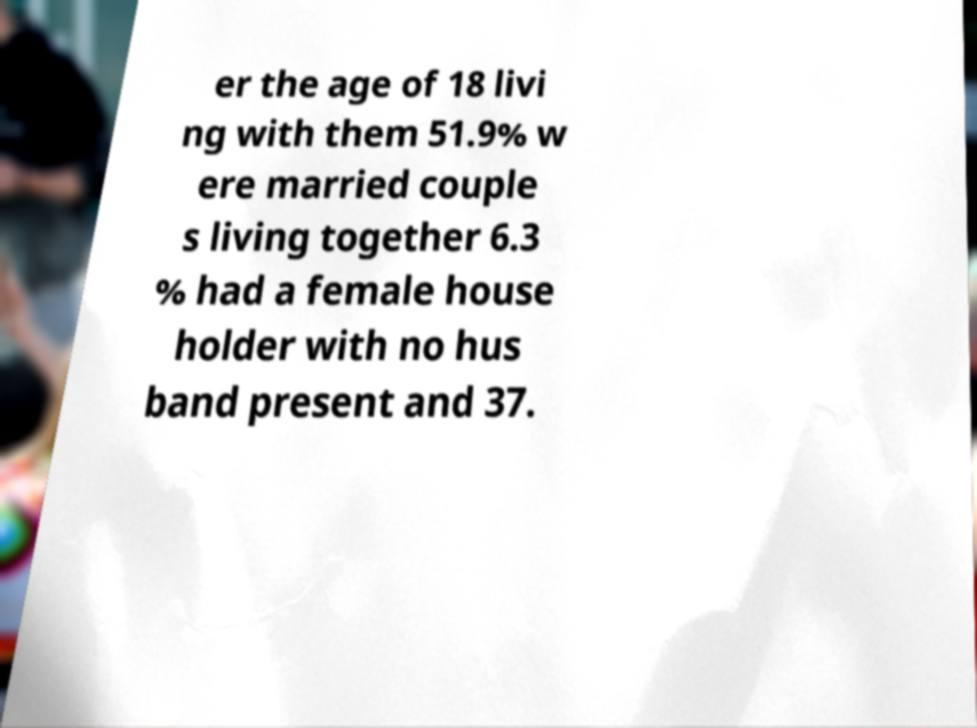What messages or text are displayed in this image? I need them in a readable, typed format. er the age of 18 livi ng with them 51.9% w ere married couple s living together 6.3 % had a female house holder with no hus band present and 37. 